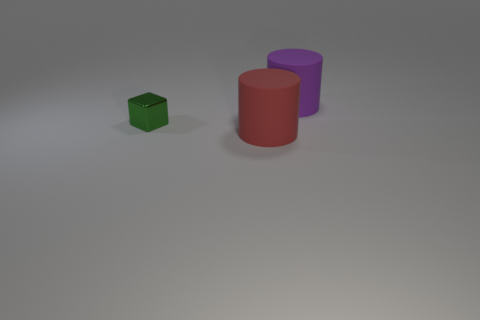Do the red matte object and the purple rubber thing have the same size?
Provide a short and direct response. Yes. There is another object that is made of the same material as the purple thing; what is its shape?
Ensure brevity in your answer.  Cylinder. There is a big rubber thing that is in front of the small metallic object; is its shape the same as the purple thing?
Provide a short and direct response. Yes. There is a metal block to the left of the large red object in front of the big purple cylinder; how big is it?
Offer a very short reply. Small. There is another object that is the same material as the red thing; what color is it?
Your answer should be very brief. Purple. What number of other green metal blocks are the same size as the green block?
Make the answer very short. 0. How many brown objects are big objects or cubes?
Your answer should be compact. 0. What number of objects are large matte objects or metal objects that are behind the red rubber object?
Make the answer very short. 3. There is a object on the left side of the red thing; what material is it?
Offer a terse response. Metal. There is a red thing that is the same size as the purple object; what is its shape?
Provide a succinct answer. Cylinder. 